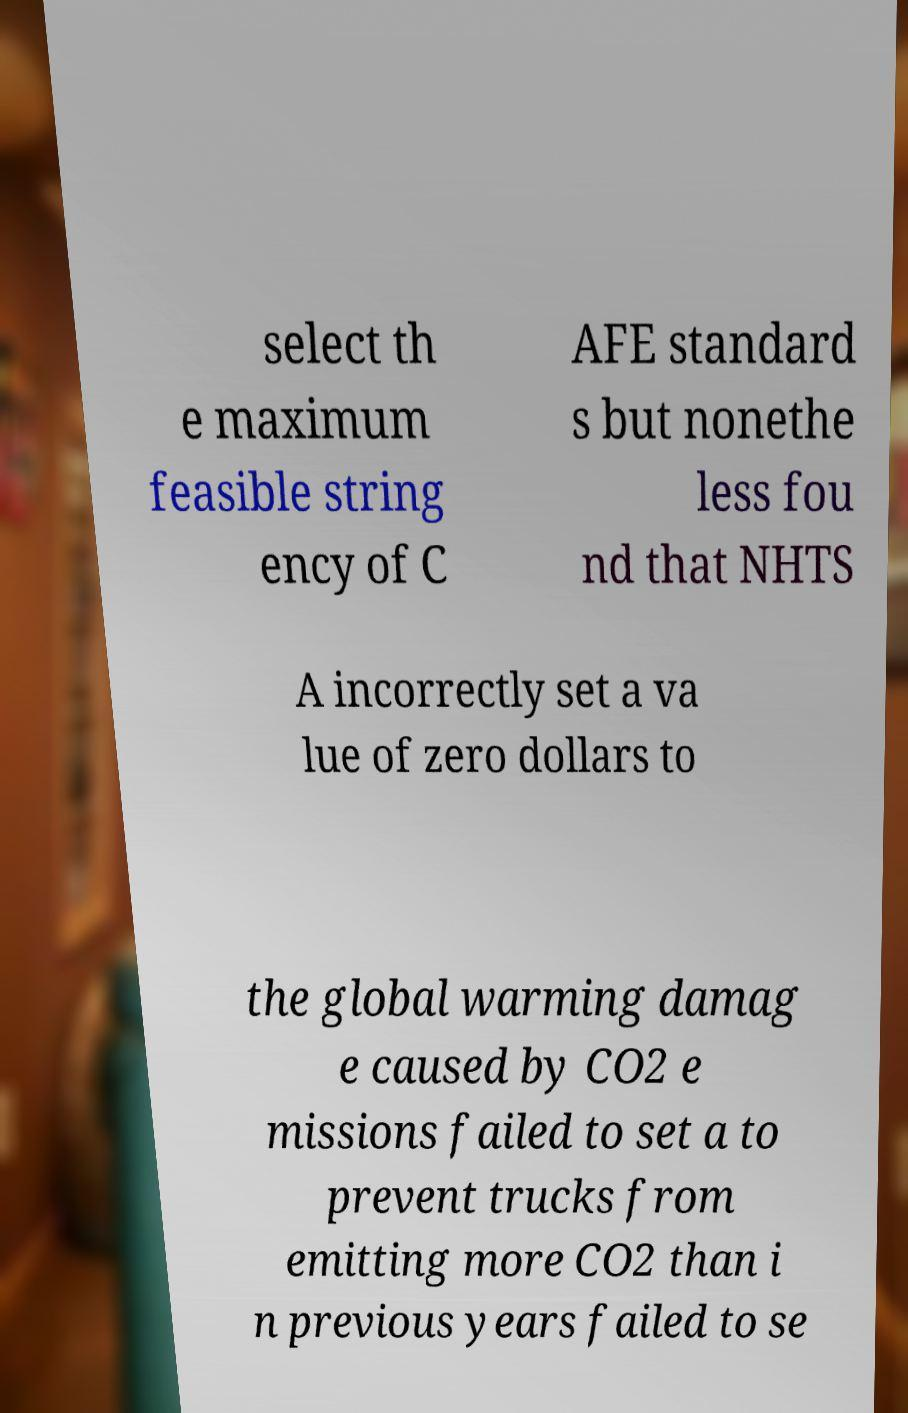There's text embedded in this image that I need extracted. Can you transcribe it verbatim? select th e maximum feasible string ency of C AFE standard s but nonethe less fou nd that NHTS A incorrectly set a va lue of zero dollars to the global warming damag e caused by CO2 e missions failed to set a to prevent trucks from emitting more CO2 than i n previous years failed to se 